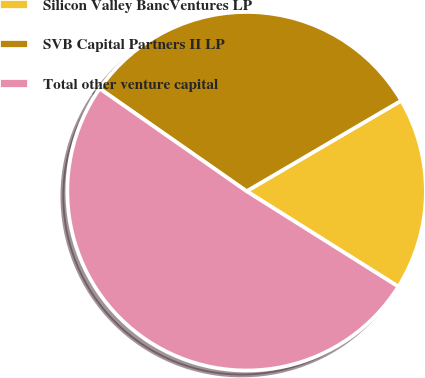<chart> <loc_0><loc_0><loc_500><loc_500><pie_chart><fcel>Silicon Valley BancVentures LP<fcel>SVB Capital Partners II LP<fcel>Total other venture capital<nl><fcel>17.37%<fcel>31.86%<fcel>50.77%<nl></chart> 